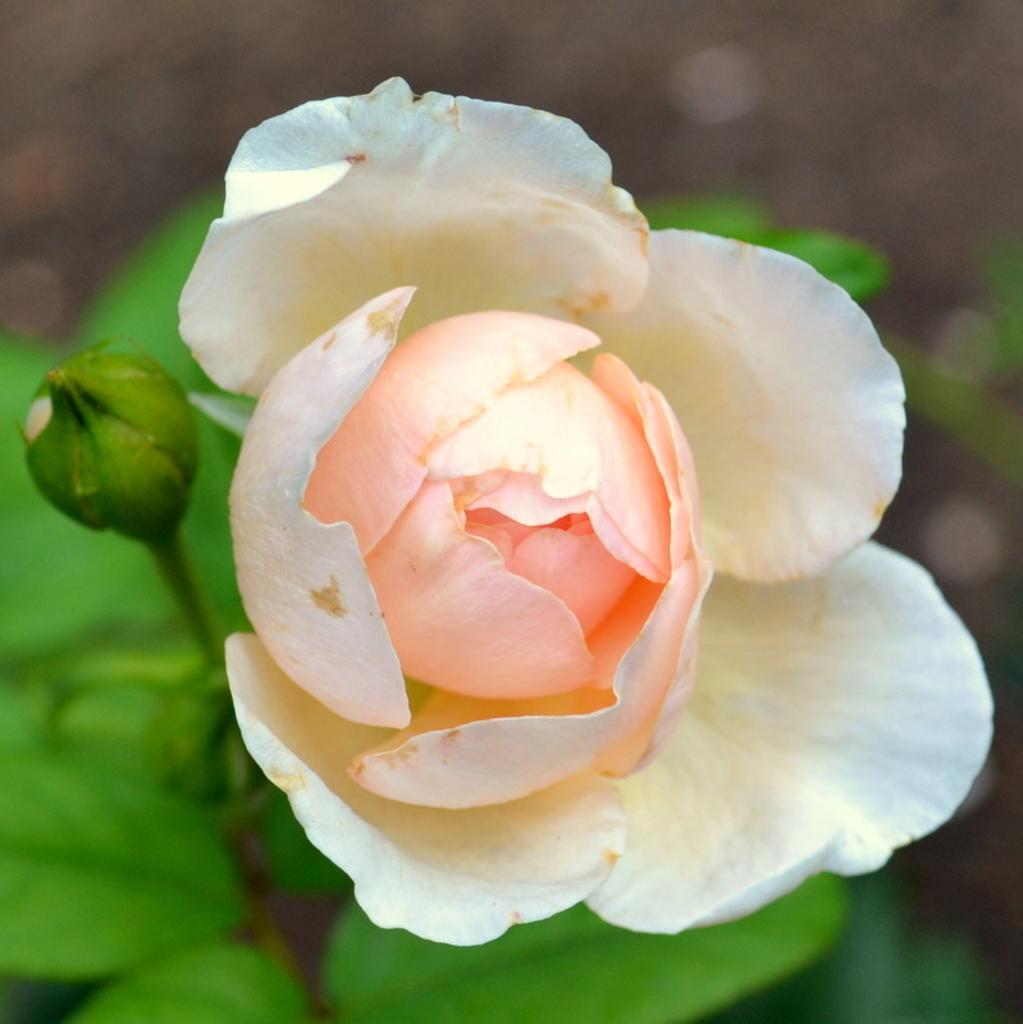Describe this image in one or two sentences. In this image we can see a flower of a plant. 